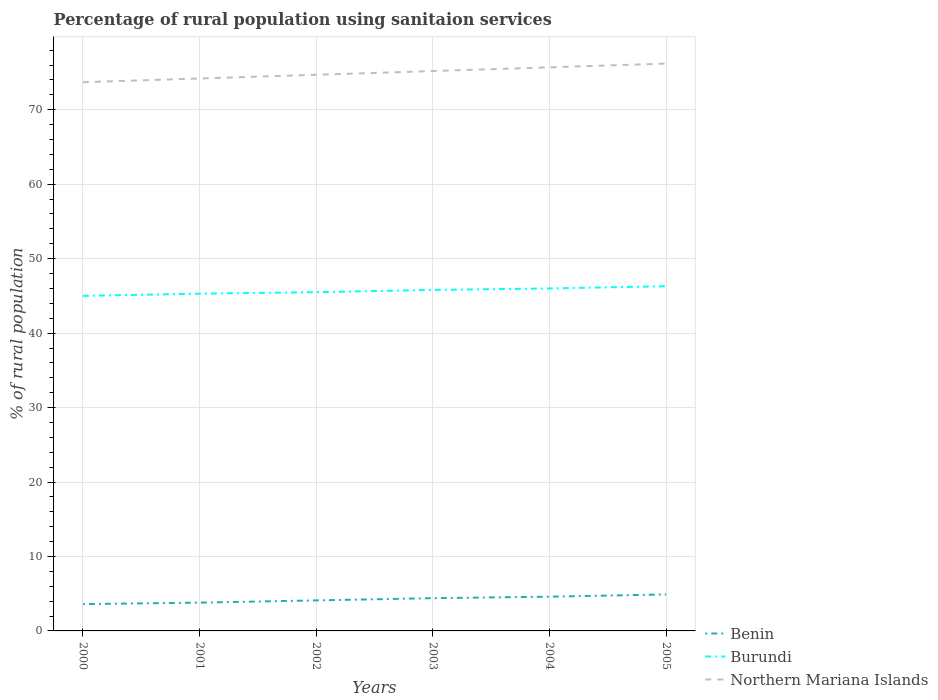How many different coloured lines are there?
Offer a very short reply. 3. Is the number of lines equal to the number of legend labels?
Your answer should be compact. Yes. Across all years, what is the maximum percentage of rural population using sanitaion services in Northern Mariana Islands?
Make the answer very short. 73.7. What is the difference between the highest and the lowest percentage of rural population using sanitaion services in Benin?
Provide a short and direct response. 3. How many lines are there?
Your answer should be very brief. 3. What is the difference between two consecutive major ticks on the Y-axis?
Ensure brevity in your answer.  10. Are the values on the major ticks of Y-axis written in scientific E-notation?
Keep it short and to the point. No. Does the graph contain any zero values?
Provide a short and direct response. No. How many legend labels are there?
Your answer should be very brief. 3. How are the legend labels stacked?
Your response must be concise. Vertical. What is the title of the graph?
Your answer should be compact. Percentage of rural population using sanitaion services. Does "Guinea-Bissau" appear as one of the legend labels in the graph?
Provide a succinct answer. No. What is the label or title of the X-axis?
Your answer should be very brief. Years. What is the label or title of the Y-axis?
Offer a very short reply. % of rural population. What is the % of rural population in Burundi in 2000?
Provide a succinct answer. 45. What is the % of rural population in Northern Mariana Islands in 2000?
Ensure brevity in your answer.  73.7. What is the % of rural population of Benin in 2001?
Your answer should be compact. 3.8. What is the % of rural population of Burundi in 2001?
Give a very brief answer. 45.3. What is the % of rural population of Northern Mariana Islands in 2001?
Your answer should be compact. 74.2. What is the % of rural population in Benin in 2002?
Your answer should be very brief. 4.1. What is the % of rural population in Burundi in 2002?
Give a very brief answer. 45.5. What is the % of rural population of Northern Mariana Islands in 2002?
Keep it short and to the point. 74.7. What is the % of rural population of Burundi in 2003?
Keep it short and to the point. 45.8. What is the % of rural population of Northern Mariana Islands in 2003?
Your answer should be compact. 75.2. What is the % of rural population in Benin in 2004?
Ensure brevity in your answer.  4.6. What is the % of rural population in Burundi in 2004?
Make the answer very short. 46. What is the % of rural population in Northern Mariana Islands in 2004?
Offer a very short reply. 75.7. What is the % of rural population in Benin in 2005?
Make the answer very short. 4.9. What is the % of rural population of Burundi in 2005?
Provide a short and direct response. 46.3. What is the % of rural population in Northern Mariana Islands in 2005?
Provide a short and direct response. 76.2. Across all years, what is the maximum % of rural population of Benin?
Ensure brevity in your answer.  4.9. Across all years, what is the maximum % of rural population in Burundi?
Ensure brevity in your answer.  46.3. Across all years, what is the maximum % of rural population of Northern Mariana Islands?
Your answer should be compact. 76.2. Across all years, what is the minimum % of rural population in Northern Mariana Islands?
Make the answer very short. 73.7. What is the total % of rural population of Benin in the graph?
Provide a succinct answer. 25.4. What is the total % of rural population in Burundi in the graph?
Your answer should be very brief. 273.9. What is the total % of rural population in Northern Mariana Islands in the graph?
Provide a short and direct response. 449.7. What is the difference between the % of rural population in Benin in 2000 and that in 2002?
Offer a terse response. -0.5. What is the difference between the % of rural population of Burundi in 2000 and that in 2002?
Offer a very short reply. -0.5. What is the difference between the % of rural population in Benin in 2000 and that in 2003?
Your answer should be very brief. -0.8. What is the difference between the % of rural population in Burundi in 2000 and that in 2003?
Make the answer very short. -0.8. What is the difference between the % of rural population of Burundi in 2000 and that in 2004?
Provide a short and direct response. -1. What is the difference between the % of rural population of Northern Mariana Islands in 2000 and that in 2004?
Give a very brief answer. -2. What is the difference between the % of rural population in Northern Mariana Islands in 2000 and that in 2005?
Ensure brevity in your answer.  -2.5. What is the difference between the % of rural population in Benin in 2001 and that in 2002?
Offer a terse response. -0.3. What is the difference between the % of rural population of Burundi in 2001 and that in 2002?
Keep it short and to the point. -0.2. What is the difference between the % of rural population in Northern Mariana Islands in 2001 and that in 2003?
Give a very brief answer. -1. What is the difference between the % of rural population in Benin in 2001 and that in 2004?
Offer a terse response. -0.8. What is the difference between the % of rural population in Burundi in 2001 and that in 2004?
Provide a succinct answer. -0.7. What is the difference between the % of rural population of Northern Mariana Islands in 2001 and that in 2004?
Provide a succinct answer. -1.5. What is the difference between the % of rural population of Burundi in 2001 and that in 2005?
Ensure brevity in your answer.  -1. What is the difference between the % of rural population in Benin in 2002 and that in 2003?
Offer a terse response. -0.3. What is the difference between the % of rural population in Northern Mariana Islands in 2002 and that in 2003?
Give a very brief answer. -0.5. What is the difference between the % of rural population in Benin in 2002 and that in 2004?
Give a very brief answer. -0.5. What is the difference between the % of rural population of Burundi in 2002 and that in 2004?
Offer a very short reply. -0.5. What is the difference between the % of rural population in Northern Mariana Islands in 2002 and that in 2004?
Make the answer very short. -1. What is the difference between the % of rural population of Benin in 2003 and that in 2004?
Ensure brevity in your answer.  -0.2. What is the difference between the % of rural population in Burundi in 2003 and that in 2004?
Your response must be concise. -0.2. What is the difference between the % of rural population of Burundi in 2004 and that in 2005?
Your answer should be very brief. -0.3. What is the difference between the % of rural population of Benin in 2000 and the % of rural population of Burundi in 2001?
Provide a short and direct response. -41.7. What is the difference between the % of rural population of Benin in 2000 and the % of rural population of Northern Mariana Islands in 2001?
Provide a succinct answer. -70.6. What is the difference between the % of rural population in Burundi in 2000 and the % of rural population in Northern Mariana Islands in 2001?
Offer a very short reply. -29.2. What is the difference between the % of rural population in Benin in 2000 and the % of rural population in Burundi in 2002?
Provide a succinct answer. -41.9. What is the difference between the % of rural population of Benin in 2000 and the % of rural population of Northern Mariana Islands in 2002?
Your answer should be compact. -71.1. What is the difference between the % of rural population of Burundi in 2000 and the % of rural population of Northern Mariana Islands in 2002?
Offer a terse response. -29.7. What is the difference between the % of rural population in Benin in 2000 and the % of rural population in Burundi in 2003?
Your response must be concise. -42.2. What is the difference between the % of rural population of Benin in 2000 and the % of rural population of Northern Mariana Islands in 2003?
Make the answer very short. -71.6. What is the difference between the % of rural population of Burundi in 2000 and the % of rural population of Northern Mariana Islands in 2003?
Give a very brief answer. -30.2. What is the difference between the % of rural population of Benin in 2000 and the % of rural population of Burundi in 2004?
Your response must be concise. -42.4. What is the difference between the % of rural population of Benin in 2000 and the % of rural population of Northern Mariana Islands in 2004?
Provide a short and direct response. -72.1. What is the difference between the % of rural population of Burundi in 2000 and the % of rural population of Northern Mariana Islands in 2004?
Provide a short and direct response. -30.7. What is the difference between the % of rural population of Benin in 2000 and the % of rural population of Burundi in 2005?
Keep it short and to the point. -42.7. What is the difference between the % of rural population in Benin in 2000 and the % of rural population in Northern Mariana Islands in 2005?
Make the answer very short. -72.6. What is the difference between the % of rural population of Burundi in 2000 and the % of rural population of Northern Mariana Islands in 2005?
Ensure brevity in your answer.  -31.2. What is the difference between the % of rural population in Benin in 2001 and the % of rural population in Burundi in 2002?
Your answer should be compact. -41.7. What is the difference between the % of rural population in Benin in 2001 and the % of rural population in Northern Mariana Islands in 2002?
Give a very brief answer. -70.9. What is the difference between the % of rural population in Burundi in 2001 and the % of rural population in Northern Mariana Islands in 2002?
Give a very brief answer. -29.4. What is the difference between the % of rural population of Benin in 2001 and the % of rural population of Burundi in 2003?
Keep it short and to the point. -42. What is the difference between the % of rural population of Benin in 2001 and the % of rural population of Northern Mariana Islands in 2003?
Give a very brief answer. -71.4. What is the difference between the % of rural population of Burundi in 2001 and the % of rural population of Northern Mariana Islands in 2003?
Your answer should be compact. -29.9. What is the difference between the % of rural population of Benin in 2001 and the % of rural population of Burundi in 2004?
Give a very brief answer. -42.2. What is the difference between the % of rural population in Benin in 2001 and the % of rural population in Northern Mariana Islands in 2004?
Provide a short and direct response. -71.9. What is the difference between the % of rural population in Burundi in 2001 and the % of rural population in Northern Mariana Islands in 2004?
Make the answer very short. -30.4. What is the difference between the % of rural population of Benin in 2001 and the % of rural population of Burundi in 2005?
Give a very brief answer. -42.5. What is the difference between the % of rural population of Benin in 2001 and the % of rural population of Northern Mariana Islands in 2005?
Keep it short and to the point. -72.4. What is the difference between the % of rural population of Burundi in 2001 and the % of rural population of Northern Mariana Islands in 2005?
Your answer should be very brief. -30.9. What is the difference between the % of rural population in Benin in 2002 and the % of rural population in Burundi in 2003?
Give a very brief answer. -41.7. What is the difference between the % of rural population of Benin in 2002 and the % of rural population of Northern Mariana Islands in 2003?
Offer a very short reply. -71.1. What is the difference between the % of rural population in Burundi in 2002 and the % of rural population in Northern Mariana Islands in 2003?
Provide a succinct answer. -29.7. What is the difference between the % of rural population in Benin in 2002 and the % of rural population in Burundi in 2004?
Provide a short and direct response. -41.9. What is the difference between the % of rural population in Benin in 2002 and the % of rural population in Northern Mariana Islands in 2004?
Ensure brevity in your answer.  -71.6. What is the difference between the % of rural population of Burundi in 2002 and the % of rural population of Northern Mariana Islands in 2004?
Provide a succinct answer. -30.2. What is the difference between the % of rural population of Benin in 2002 and the % of rural population of Burundi in 2005?
Provide a short and direct response. -42.2. What is the difference between the % of rural population of Benin in 2002 and the % of rural population of Northern Mariana Islands in 2005?
Provide a short and direct response. -72.1. What is the difference between the % of rural population of Burundi in 2002 and the % of rural population of Northern Mariana Islands in 2005?
Provide a short and direct response. -30.7. What is the difference between the % of rural population in Benin in 2003 and the % of rural population in Burundi in 2004?
Your response must be concise. -41.6. What is the difference between the % of rural population of Benin in 2003 and the % of rural population of Northern Mariana Islands in 2004?
Give a very brief answer. -71.3. What is the difference between the % of rural population in Burundi in 2003 and the % of rural population in Northern Mariana Islands in 2004?
Your answer should be very brief. -29.9. What is the difference between the % of rural population of Benin in 2003 and the % of rural population of Burundi in 2005?
Your answer should be very brief. -41.9. What is the difference between the % of rural population in Benin in 2003 and the % of rural population in Northern Mariana Islands in 2005?
Provide a succinct answer. -71.8. What is the difference between the % of rural population of Burundi in 2003 and the % of rural population of Northern Mariana Islands in 2005?
Provide a succinct answer. -30.4. What is the difference between the % of rural population in Benin in 2004 and the % of rural population in Burundi in 2005?
Provide a short and direct response. -41.7. What is the difference between the % of rural population of Benin in 2004 and the % of rural population of Northern Mariana Islands in 2005?
Make the answer very short. -71.6. What is the difference between the % of rural population in Burundi in 2004 and the % of rural population in Northern Mariana Islands in 2005?
Give a very brief answer. -30.2. What is the average % of rural population of Benin per year?
Your response must be concise. 4.23. What is the average % of rural population in Burundi per year?
Give a very brief answer. 45.65. What is the average % of rural population of Northern Mariana Islands per year?
Your answer should be compact. 74.95. In the year 2000, what is the difference between the % of rural population of Benin and % of rural population of Burundi?
Ensure brevity in your answer.  -41.4. In the year 2000, what is the difference between the % of rural population in Benin and % of rural population in Northern Mariana Islands?
Keep it short and to the point. -70.1. In the year 2000, what is the difference between the % of rural population of Burundi and % of rural population of Northern Mariana Islands?
Offer a terse response. -28.7. In the year 2001, what is the difference between the % of rural population of Benin and % of rural population of Burundi?
Your answer should be very brief. -41.5. In the year 2001, what is the difference between the % of rural population of Benin and % of rural population of Northern Mariana Islands?
Provide a short and direct response. -70.4. In the year 2001, what is the difference between the % of rural population of Burundi and % of rural population of Northern Mariana Islands?
Provide a short and direct response. -28.9. In the year 2002, what is the difference between the % of rural population in Benin and % of rural population in Burundi?
Keep it short and to the point. -41.4. In the year 2002, what is the difference between the % of rural population of Benin and % of rural population of Northern Mariana Islands?
Provide a short and direct response. -70.6. In the year 2002, what is the difference between the % of rural population in Burundi and % of rural population in Northern Mariana Islands?
Your response must be concise. -29.2. In the year 2003, what is the difference between the % of rural population in Benin and % of rural population in Burundi?
Keep it short and to the point. -41.4. In the year 2003, what is the difference between the % of rural population in Benin and % of rural population in Northern Mariana Islands?
Give a very brief answer. -70.8. In the year 2003, what is the difference between the % of rural population in Burundi and % of rural population in Northern Mariana Islands?
Offer a terse response. -29.4. In the year 2004, what is the difference between the % of rural population of Benin and % of rural population of Burundi?
Keep it short and to the point. -41.4. In the year 2004, what is the difference between the % of rural population of Benin and % of rural population of Northern Mariana Islands?
Offer a terse response. -71.1. In the year 2004, what is the difference between the % of rural population of Burundi and % of rural population of Northern Mariana Islands?
Offer a very short reply. -29.7. In the year 2005, what is the difference between the % of rural population of Benin and % of rural population of Burundi?
Offer a terse response. -41.4. In the year 2005, what is the difference between the % of rural population in Benin and % of rural population in Northern Mariana Islands?
Give a very brief answer. -71.3. In the year 2005, what is the difference between the % of rural population in Burundi and % of rural population in Northern Mariana Islands?
Offer a very short reply. -29.9. What is the ratio of the % of rural population of Benin in 2000 to that in 2001?
Offer a very short reply. 0.95. What is the ratio of the % of rural population in Benin in 2000 to that in 2002?
Provide a short and direct response. 0.88. What is the ratio of the % of rural population in Northern Mariana Islands in 2000 to that in 2002?
Offer a very short reply. 0.99. What is the ratio of the % of rural population in Benin in 2000 to that in 2003?
Offer a terse response. 0.82. What is the ratio of the % of rural population in Burundi in 2000 to that in 2003?
Your answer should be compact. 0.98. What is the ratio of the % of rural population of Northern Mariana Islands in 2000 to that in 2003?
Keep it short and to the point. 0.98. What is the ratio of the % of rural population of Benin in 2000 to that in 2004?
Offer a very short reply. 0.78. What is the ratio of the % of rural population in Burundi in 2000 to that in 2004?
Provide a succinct answer. 0.98. What is the ratio of the % of rural population in Northern Mariana Islands in 2000 to that in 2004?
Provide a succinct answer. 0.97. What is the ratio of the % of rural population of Benin in 2000 to that in 2005?
Offer a terse response. 0.73. What is the ratio of the % of rural population of Burundi in 2000 to that in 2005?
Keep it short and to the point. 0.97. What is the ratio of the % of rural population of Northern Mariana Islands in 2000 to that in 2005?
Offer a very short reply. 0.97. What is the ratio of the % of rural population in Benin in 2001 to that in 2002?
Ensure brevity in your answer.  0.93. What is the ratio of the % of rural population in Burundi in 2001 to that in 2002?
Provide a succinct answer. 1. What is the ratio of the % of rural population in Northern Mariana Islands in 2001 to that in 2002?
Offer a terse response. 0.99. What is the ratio of the % of rural population in Benin in 2001 to that in 2003?
Offer a terse response. 0.86. What is the ratio of the % of rural population in Northern Mariana Islands in 2001 to that in 2003?
Give a very brief answer. 0.99. What is the ratio of the % of rural population of Benin in 2001 to that in 2004?
Keep it short and to the point. 0.83. What is the ratio of the % of rural population in Northern Mariana Islands in 2001 to that in 2004?
Keep it short and to the point. 0.98. What is the ratio of the % of rural population in Benin in 2001 to that in 2005?
Your answer should be very brief. 0.78. What is the ratio of the % of rural population of Burundi in 2001 to that in 2005?
Your response must be concise. 0.98. What is the ratio of the % of rural population in Northern Mariana Islands in 2001 to that in 2005?
Offer a terse response. 0.97. What is the ratio of the % of rural population in Benin in 2002 to that in 2003?
Your response must be concise. 0.93. What is the ratio of the % of rural population in Burundi in 2002 to that in 2003?
Provide a short and direct response. 0.99. What is the ratio of the % of rural population in Northern Mariana Islands in 2002 to that in 2003?
Your answer should be compact. 0.99. What is the ratio of the % of rural population in Benin in 2002 to that in 2004?
Offer a very short reply. 0.89. What is the ratio of the % of rural population of Northern Mariana Islands in 2002 to that in 2004?
Make the answer very short. 0.99. What is the ratio of the % of rural population in Benin in 2002 to that in 2005?
Offer a terse response. 0.84. What is the ratio of the % of rural population of Burundi in 2002 to that in 2005?
Your answer should be very brief. 0.98. What is the ratio of the % of rural population of Northern Mariana Islands in 2002 to that in 2005?
Your response must be concise. 0.98. What is the ratio of the % of rural population of Benin in 2003 to that in 2004?
Your answer should be very brief. 0.96. What is the ratio of the % of rural population in Burundi in 2003 to that in 2004?
Make the answer very short. 1. What is the ratio of the % of rural population of Benin in 2003 to that in 2005?
Your answer should be compact. 0.9. What is the ratio of the % of rural population of Burundi in 2003 to that in 2005?
Provide a succinct answer. 0.99. What is the ratio of the % of rural population of Northern Mariana Islands in 2003 to that in 2005?
Your response must be concise. 0.99. What is the ratio of the % of rural population of Benin in 2004 to that in 2005?
Your answer should be very brief. 0.94. What is the difference between the highest and the second highest % of rural population in Benin?
Give a very brief answer. 0.3. What is the difference between the highest and the second highest % of rural population of Burundi?
Your response must be concise. 0.3. What is the difference between the highest and the second highest % of rural population of Northern Mariana Islands?
Your response must be concise. 0.5. 